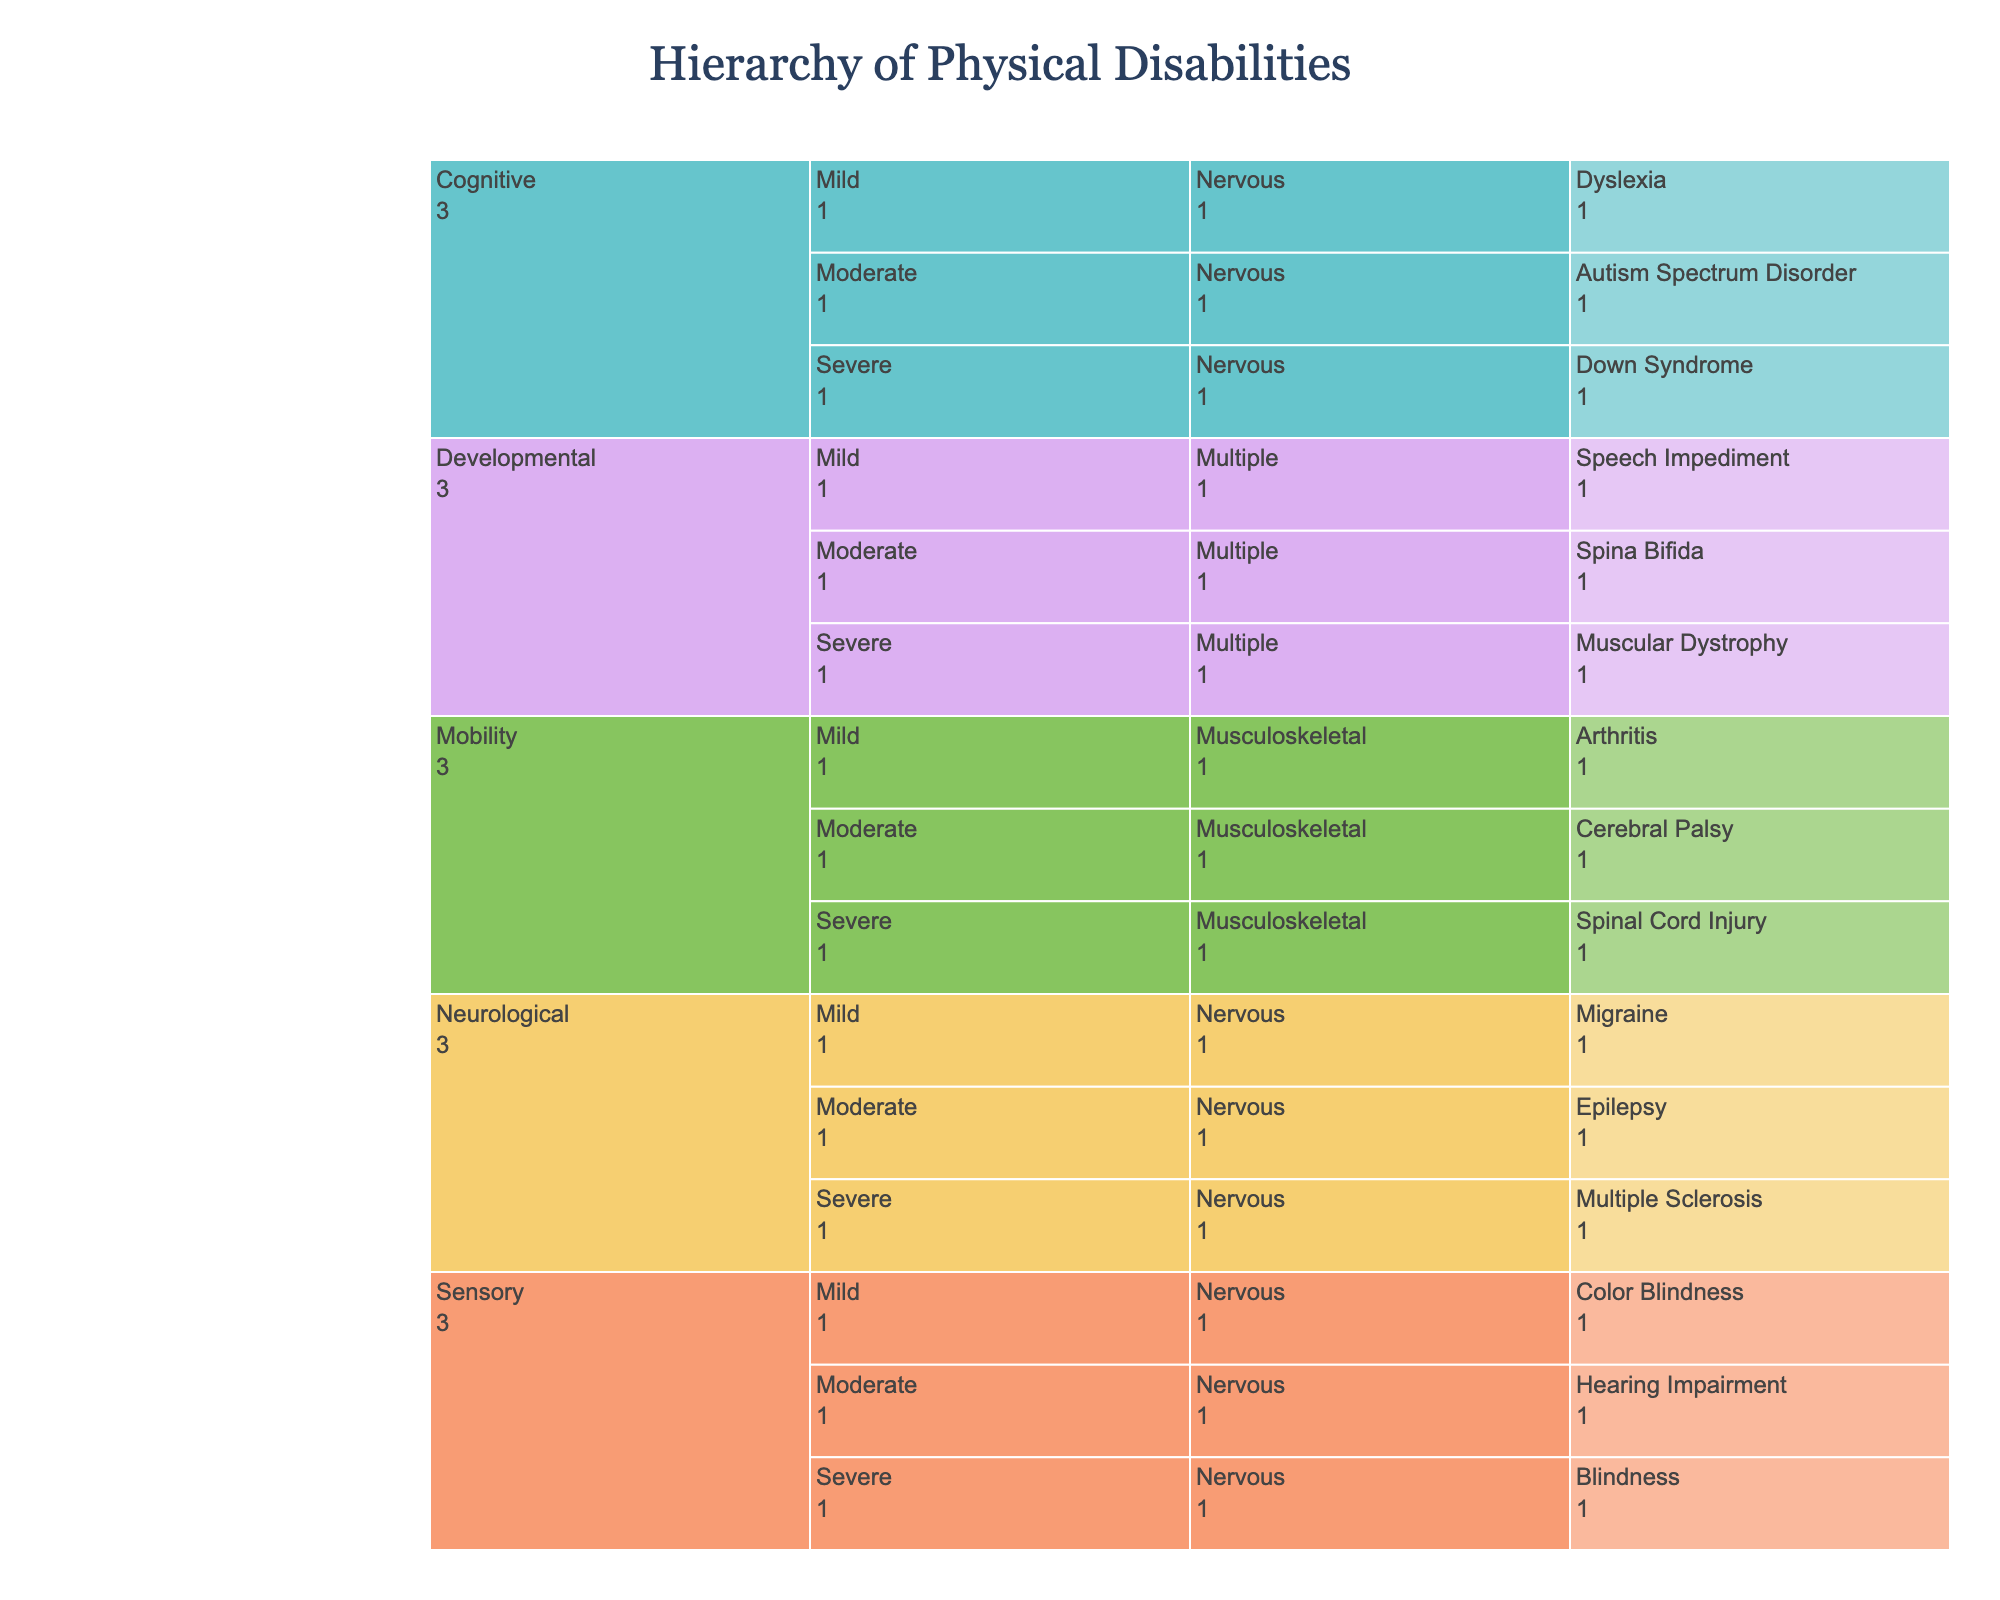Which type of disability has the most severe conditions? By looking at the top level of the icicle chart under the "Severity" category, we can see the distribution of conditions categorized as severe across different types.
Answer: Mobility How many specific conditions are classified under "Sensory" disabilities? First, filter the path by "Type"=Sensory. Then count the number of specific conditions within this category.
Answer: 3 Which body system is affected by "Down Syndrome"? Trace the path under "Cognitive" type > "Severe" severity > following to the body system associated with "Down Syndrome".
Answer: Nervous Are there more "Moderate" or "Mild" neurological conditions? Compare the count of specific conditions listed under "Neurological" for both "Moderate" and "Mild" severities.
Answer: Moderate Which specific condition is classified as a "Severe" type of "Neurological" disability? Navigate through "Neurological" type and locate the condition listed under "Severe" severity.
Answer: Multiple Sclerosis How many conditions are affected by musculoskeletal body systems? Sum the conditions under the mobility type, as well as any other conditions affecting the musculoskeletal system from other types.
Answer: 3 What is the severity of "Epilepsy"? Locate "Epilepsy" in the icicle chart and trace back to its parent category to identify the severity.
Answer: Moderate Which type of disability affects multiple body systems the most? Check the number of conditions under the "Developmental" type which is categorized under multiple body systems.
Answer: Developmental Is "Hearing Impairment" more severe than "Color Blindness"? Both conditions are under the "Sensory" type. Compare their severity levels to determine which one is more severe.
Answer: Yes How many conditions are classified as "Mild" disabilities? Sum the "value" field for all conditions listed under the "Mild" severity category across all types.
Answer: 5 